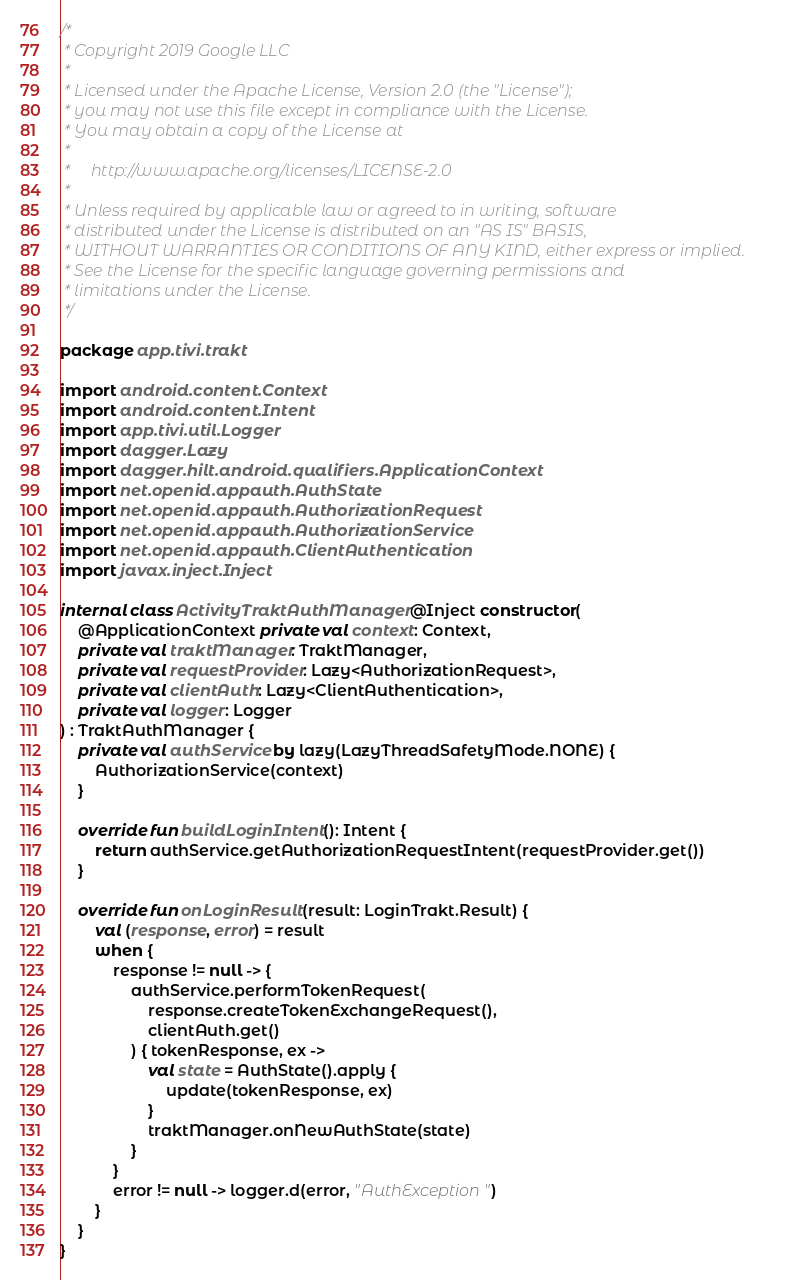Convert code to text. <code><loc_0><loc_0><loc_500><loc_500><_Kotlin_>/*
 * Copyright 2019 Google LLC
 *
 * Licensed under the Apache License, Version 2.0 (the "License");
 * you may not use this file except in compliance with the License.
 * You may obtain a copy of the License at
 *
 *     http://www.apache.org/licenses/LICENSE-2.0
 *
 * Unless required by applicable law or agreed to in writing, software
 * distributed under the License is distributed on an "AS IS" BASIS,
 * WITHOUT WARRANTIES OR CONDITIONS OF ANY KIND, either express or implied.
 * See the License for the specific language governing permissions and
 * limitations under the License.
 */

package app.tivi.trakt

import android.content.Context
import android.content.Intent
import app.tivi.util.Logger
import dagger.Lazy
import dagger.hilt.android.qualifiers.ApplicationContext
import net.openid.appauth.AuthState
import net.openid.appauth.AuthorizationRequest
import net.openid.appauth.AuthorizationService
import net.openid.appauth.ClientAuthentication
import javax.inject.Inject

internal class ActivityTraktAuthManager @Inject constructor(
    @ApplicationContext private val context: Context,
    private val traktManager: TraktManager,
    private val requestProvider: Lazy<AuthorizationRequest>,
    private val clientAuth: Lazy<ClientAuthentication>,
    private val logger: Logger
) : TraktAuthManager {
    private val authService by lazy(LazyThreadSafetyMode.NONE) {
        AuthorizationService(context)
    }

    override fun buildLoginIntent(): Intent {
        return authService.getAuthorizationRequestIntent(requestProvider.get())
    }

    override fun onLoginResult(result: LoginTrakt.Result) {
        val (response, error) = result
        when {
            response != null -> {
                authService.performTokenRequest(
                    response.createTokenExchangeRequest(),
                    clientAuth.get()
                ) { tokenResponse, ex ->
                    val state = AuthState().apply {
                        update(tokenResponse, ex)
                    }
                    traktManager.onNewAuthState(state)
                }
            }
            error != null -> logger.d(error, "AuthException")
        }
    }
}
</code> 